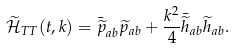Convert formula to latex. <formula><loc_0><loc_0><loc_500><loc_500>\widetilde { \mathcal { H } } _ { T T } ( t , { k } ) = \bar { \widetilde { p } } _ { a b } \widetilde { p } _ { a b } + \frac { k ^ { 2 } } { 4 } \bar { \widetilde { h } } _ { a b } \widetilde { h } _ { a b } .</formula> 